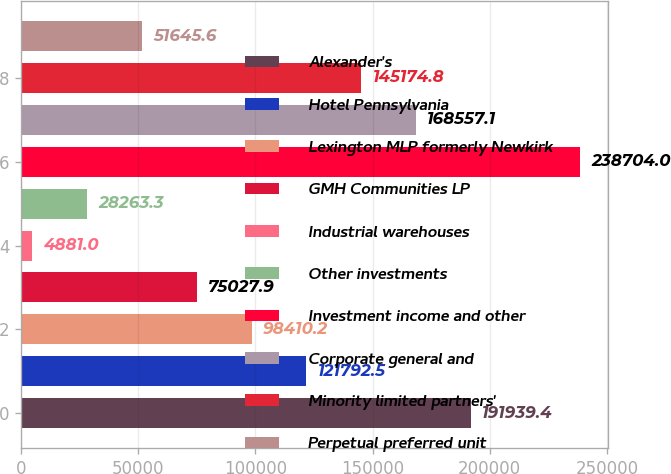<chart> <loc_0><loc_0><loc_500><loc_500><bar_chart><fcel>Alexander's<fcel>Hotel Pennsylvania<fcel>Lexington MLP formerly Newkirk<fcel>GMH Communities LP<fcel>Industrial warehouses<fcel>Other investments<fcel>Investment income and other<fcel>Corporate general and<fcel>Minority limited partners'<fcel>Perpetual preferred unit<nl><fcel>191939<fcel>121792<fcel>98410.2<fcel>75027.9<fcel>4881<fcel>28263.3<fcel>238704<fcel>168557<fcel>145175<fcel>51645.6<nl></chart> 